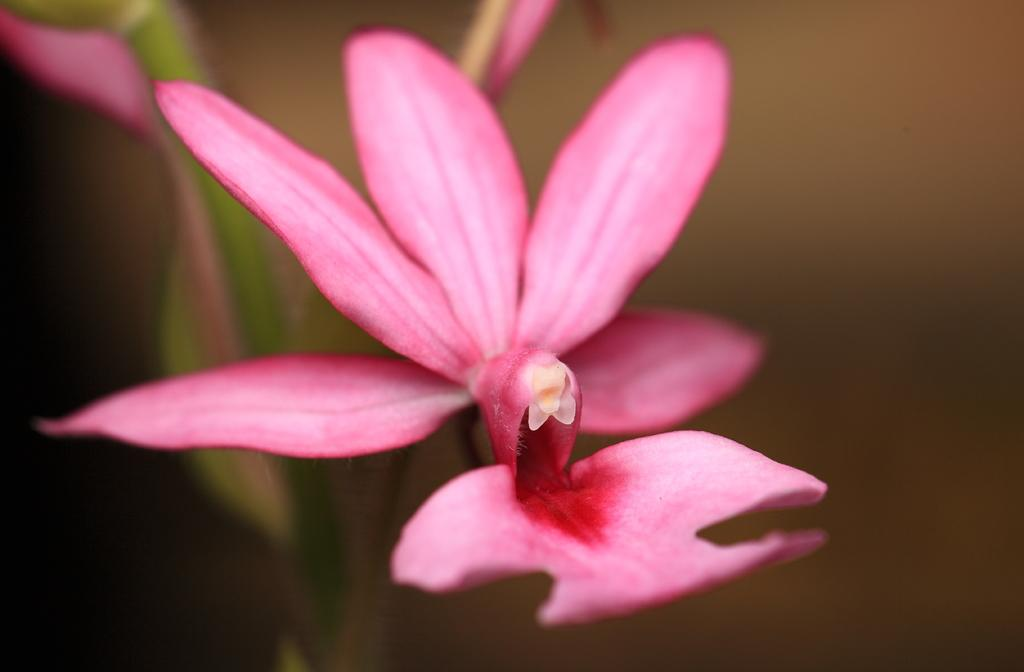What is the main subject in the foreground of the image? There is a flower in the foreground of the image. What other plant-related object can be seen in the image? There is a plant in the background of the image. How would you describe the appearance of the background in the image? The background of the image is blurred. How many beds are visible in the image? There are no beds present in the image. What type of yard is shown in the image? There is no yard shown in the image; it features a flower in the foreground and a blurred background. 